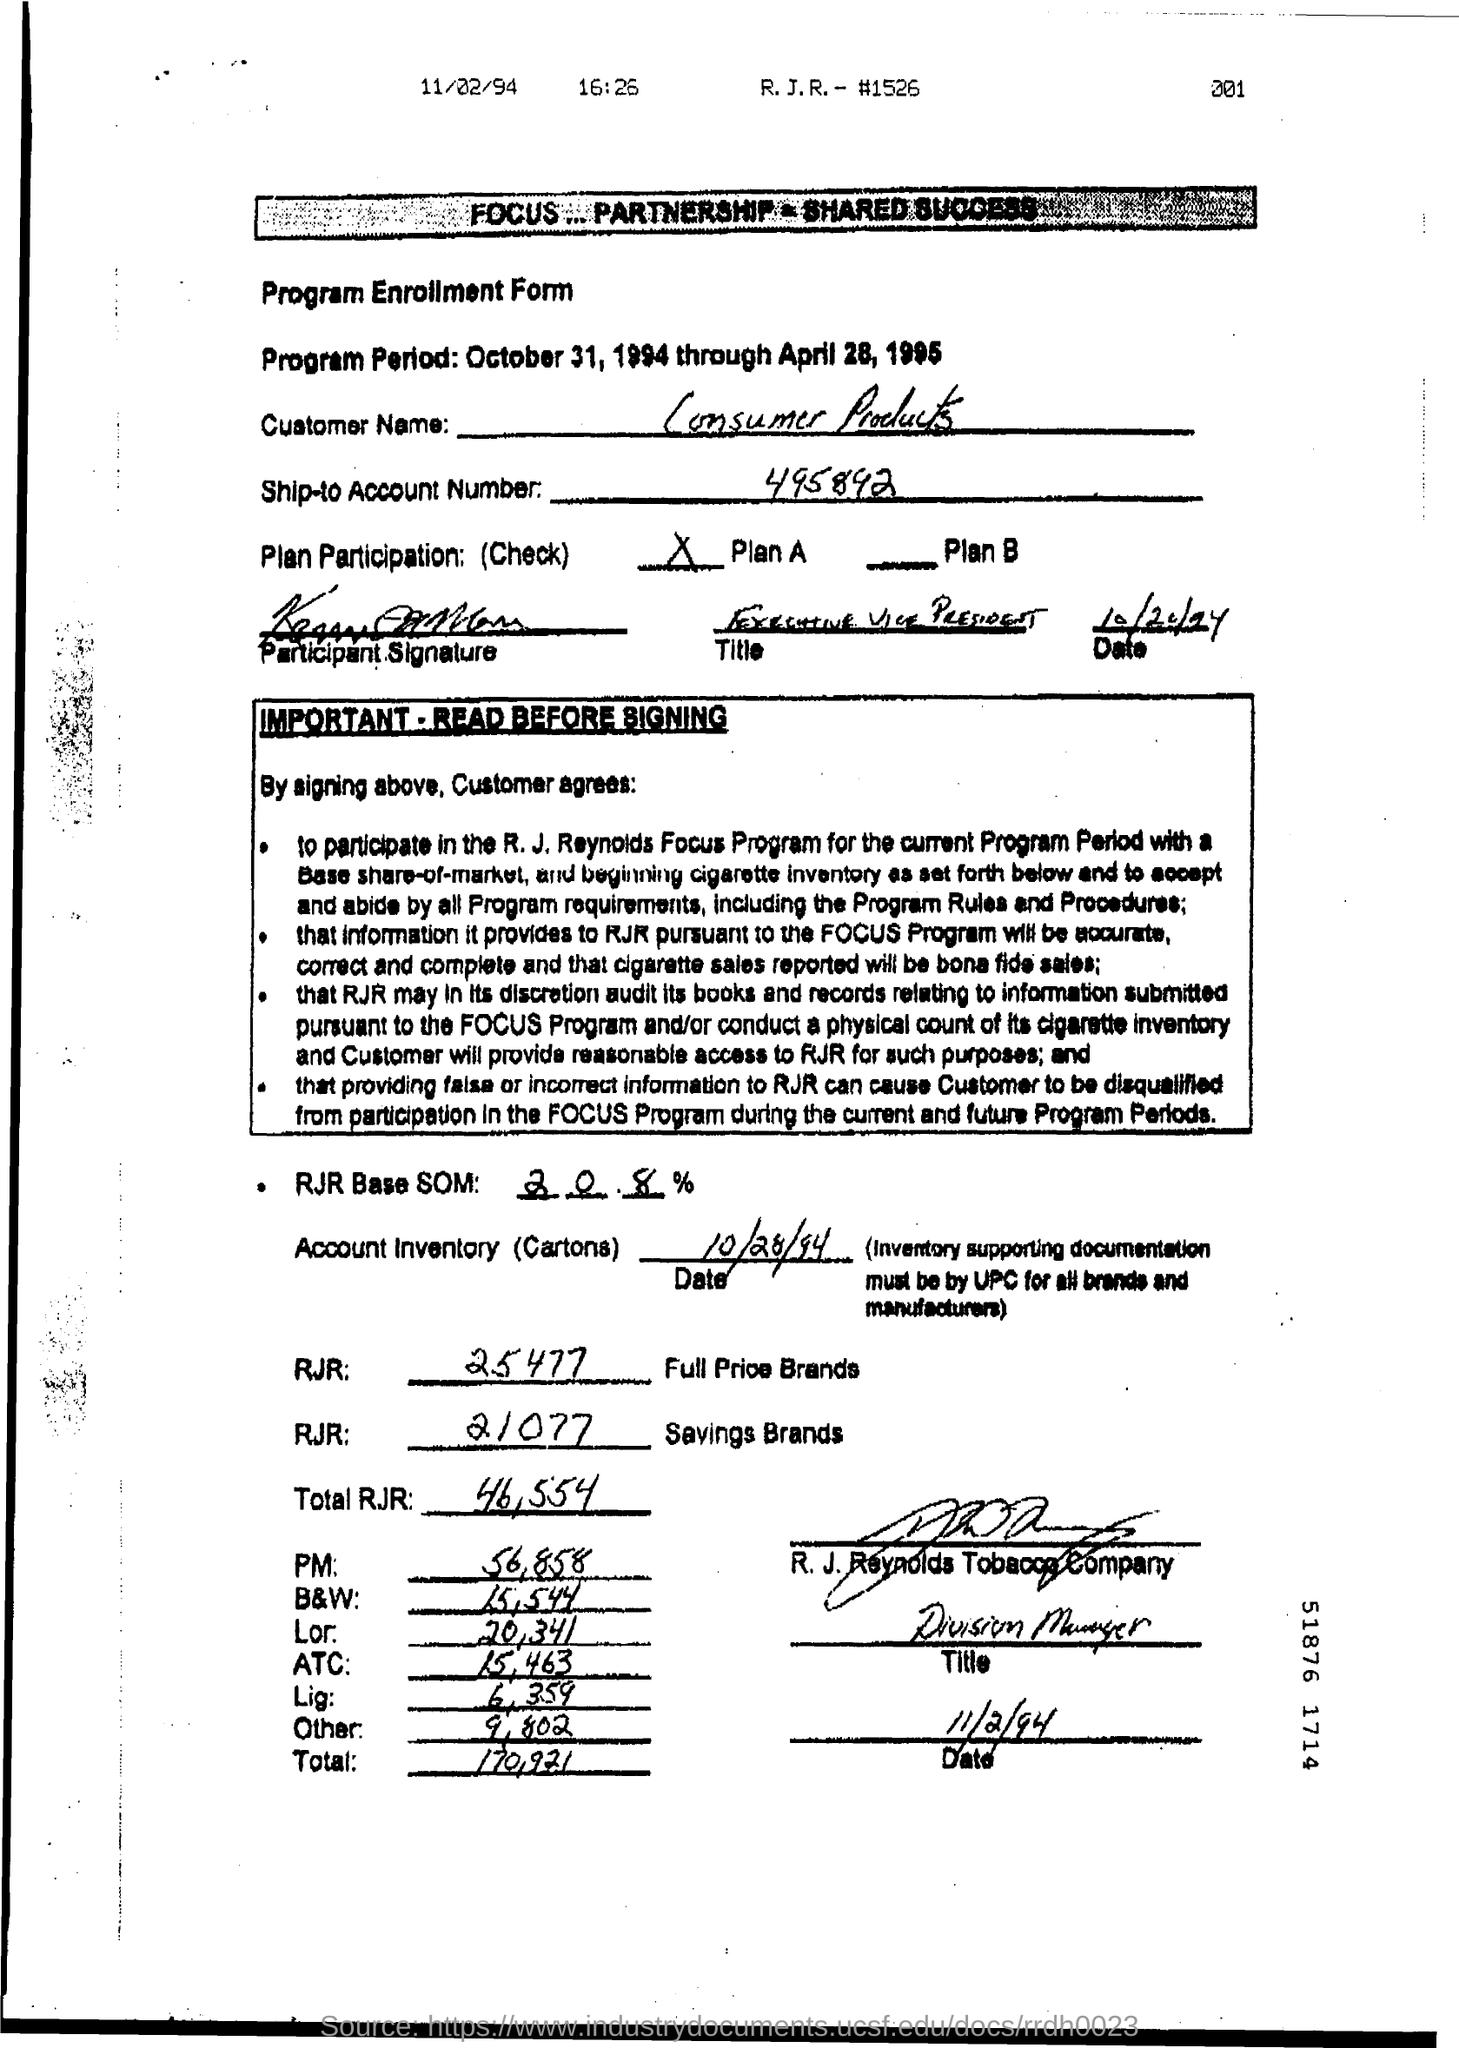What does 'RJR SOM' mean? 'RJR SOM' refers to R. J. Reynolds' Base Share of Market. It's a metric used by the company to track its market share against competitors. In this document, it's listed as 30.50%. What information is required to support the inventory? The document specifies that inventory supporting documentation must be by UPC for all brands and manufacturers, ensuring the inventory audit is accurate and verifiable. 